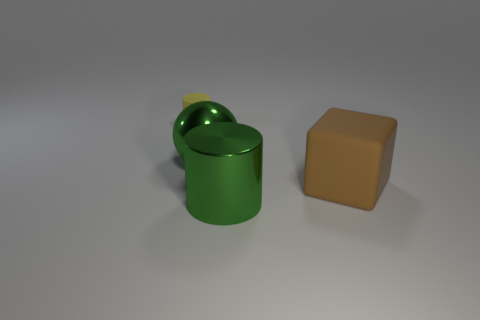Subtract all balls. How many objects are left? 3 Add 4 yellow rubber spheres. How many objects exist? 8 Add 2 rubber cylinders. How many rubber cylinders are left? 3 Add 3 red things. How many red things exist? 3 Subtract 0 gray balls. How many objects are left? 4 Subtract all big brown rubber cubes. Subtract all tiny gray objects. How many objects are left? 3 